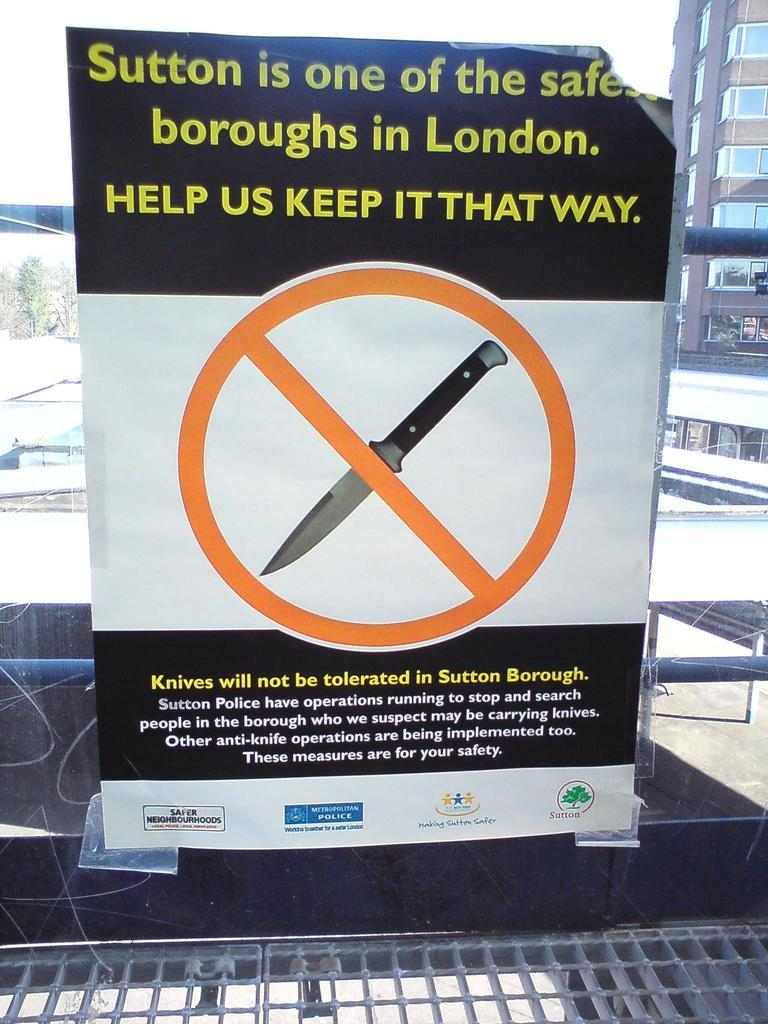<image>
Render a clear and concise summary of the photo. If visiting Sutton Burough this sign states that one should not bring a knife. 